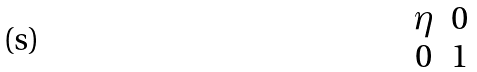Convert formula to latex. <formula><loc_0><loc_0><loc_500><loc_500>\begin{matrix} \eta & 0 \\ 0 & 1 \end{matrix}</formula> 